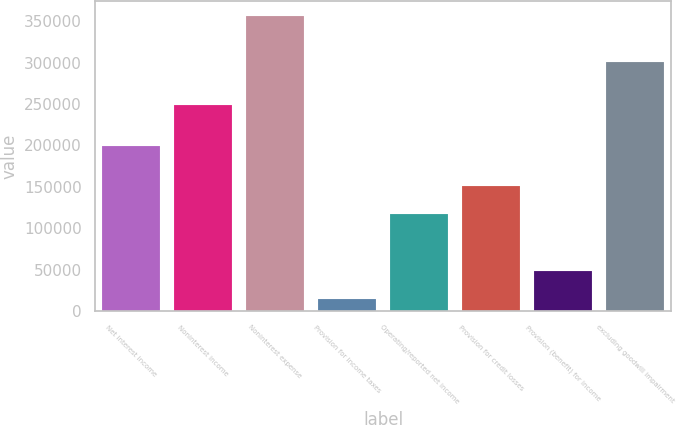<chart> <loc_0><loc_0><loc_500><loc_500><bar_chart><fcel>Net interest income<fcel>Noninterest income<fcel>Noninterest expense<fcel>Provision for income taxes<fcel>Operating/reported net income<fcel>Provision for credit losses<fcel>Provision (benefit) for income<fcel>excluding goodwill impairment<nl><fcel>199536<fcel>248764<fcel>356513<fcel>13937<fcel>116710<fcel>150967<fcel>48194.6<fcel>300799<nl></chart> 